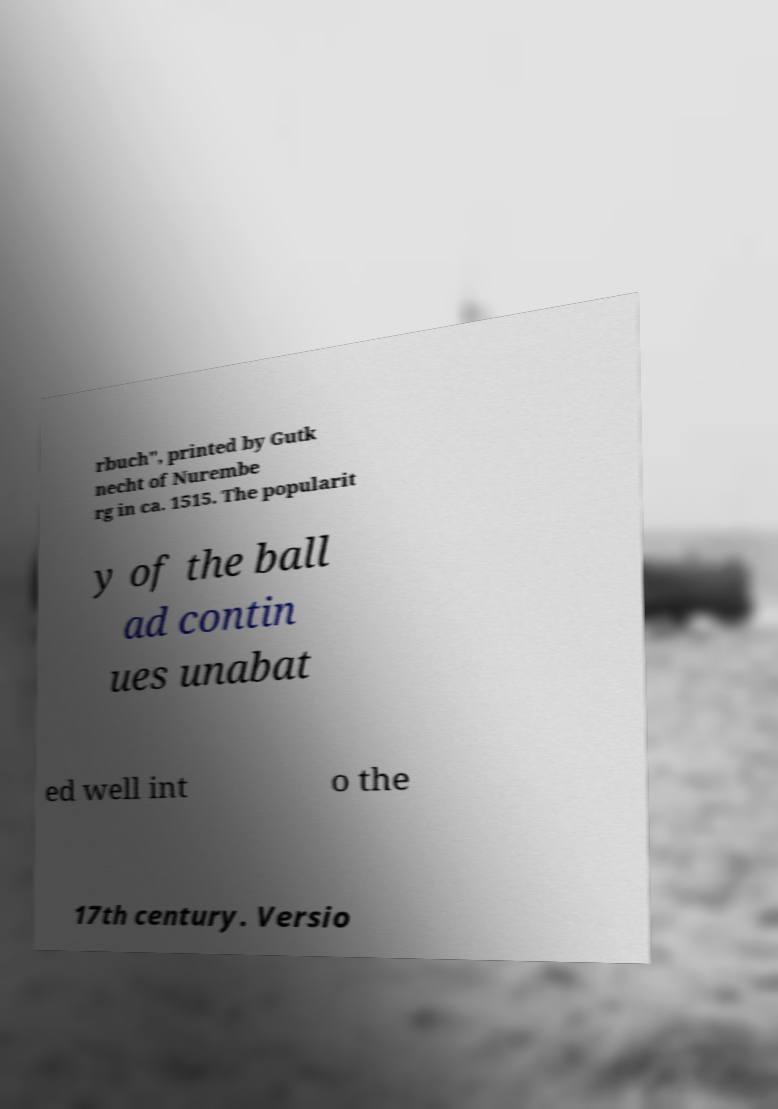Could you extract and type out the text from this image? rbuch", printed by Gutk necht of Nurembe rg in ca. 1515. The popularit y of the ball ad contin ues unabat ed well int o the 17th century. Versio 